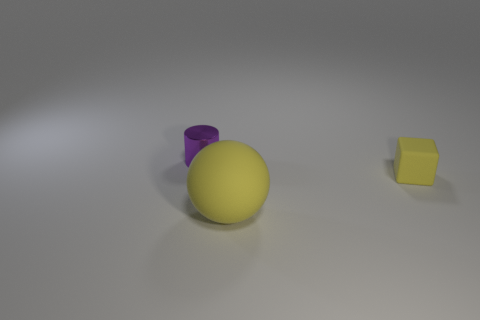How many things are both on the left side of the matte ball and on the right side of the purple metal thing?
Your response must be concise. 0. Do the matte object that is behind the yellow sphere and the small purple shiny thing have the same shape?
Ensure brevity in your answer.  No. There is a yellow block that is the same size as the purple cylinder; what is it made of?
Give a very brief answer. Rubber. Are there an equal number of small rubber cubes that are in front of the tiny yellow object and tiny shiny cylinders that are left of the big rubber sphere?
Provide a succinct answer. No. What number of big rubber balls are on the right side of the matte object to the right of the matte object to the left of the tiny yellow thing?
Offer a very short reply. 0. There is a big matte object; is it the same color as the small thing right of the purple object?
Provide a succinct answer. Yes. What size is the yellow block that is the same material as the large ball?
Your answer should be very brief. Small. Are there more rubber blocks that are in front of the tiny cylinder than big blue matte cylinders?
Provide a short and direct response. Yes. What is the material of the small object that is to the right of the matte object that is in front of the small object that is in front of the small purple cylinder?
Give a very brief answer. Rubber. Is the cube made of the same material as the tiny thing that is left of the rubber ball?
Offer a very short reply. No. 